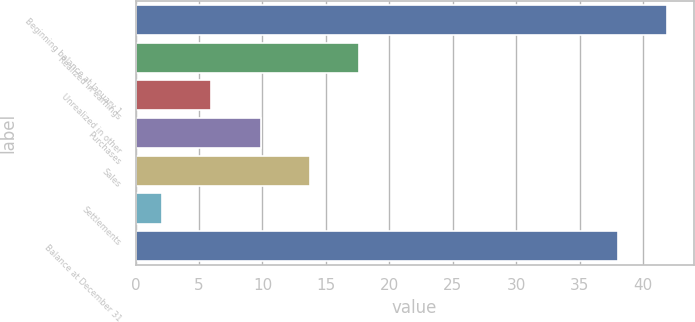Convert chart to OTSL. <chart><loc_0><loc_0><loc_500><loc_500><bar_chart><fcel>Beginning balance at January 1<fcel>Realized in earnings<fcel>Unrealized in other<fcel>Purchases<fcel>Sales<fcel>Settlements<fcel>Balance at December 31<nl><fcel>41.89<fcel>17.64<fcel>5.97<fcel>9.86<fcel>13.75<fcel>2.08<fcel>38<nl></chart> 